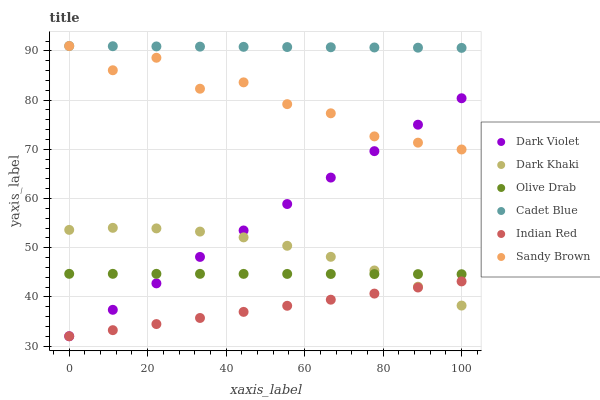Does Indian Red have the minimum area under the curve?
Answer yes or no. Yes. Does Cadet Blue have the maximum area under the curve?
Answer yes or no. Yes. Does Dark Violet have the minimum area under the curve?
Answer yes or no. No. Does Dark Violet have the maximum area under the curve?
Answer yes or no. No. Is Indian Red the smoothest?
Answer yes or no. Yes. Is Sandy Brown the roughest?
Answer yes or no. Yes. Is Dark Violet the smoothest?
Answer yes or no. No. Is Dark Violet the roughest?
Answer yes or no. No. Does Dark Violet have the lowest value?
Answer yes or no. Yes. Does Dark Khaki have the lowest value?
Answer yes or no. No. Does Sandy Brown have the highest value?
Answer yes or no. Yes. Does Dark Violet have the highest value?
Answer yes or no. No. Is Olive Drab less than Sandy Brown?
Answer yes or no. Yes. Is Cadet Blue greater than Dark Violet?
Answer yes or no. Yes. Does Dark Khaki intersect Dark Violet?
Answer yes or no. Yes. Is Dark Khaki less than Dark Violet?
Answer yes or no. No. Is Dark Khaki greater than Dark Violet?
Answer yes or no. No. Does Olive Drab intersect Sandy Brown?
Answer yes or no. No. 